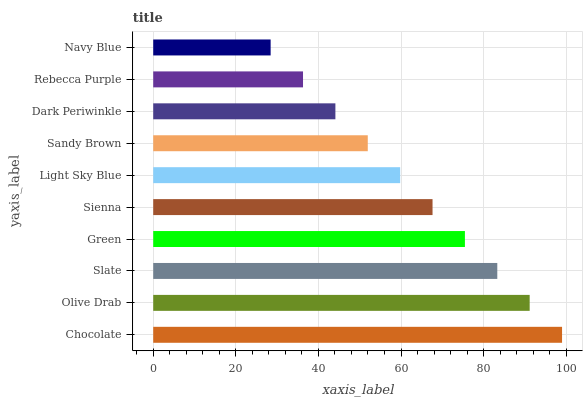Is Navy Blue the minimum?
Answer yes or no. Yes. Is Chocolate the maximum?
Answer yes or no. Yes. Is Olive Drab the minimum?
Answer yes or no. No. Is Olive Drab the maximum?
Answer yes or no. No. Is Chocolate greater than Olive Drab?
Answer yes or no. Yes. Is Olive Drab less than Chocolate?
Answer yes or no. Yes. Is Olive Drab greater than Chocolate?
Answer yes or no. No. Is Chocolate less than Olive Drab?
Answer yes or no. No. Is Sienna the high median?
Answer yes or no. Yes. Is Light Sky Blue the low median?
Answer yes or no. Yes. Is Olive Drab the high median?
Answer yes or no. No. Is Dark Periwinkle the low median?
Answer yes or no. No. 